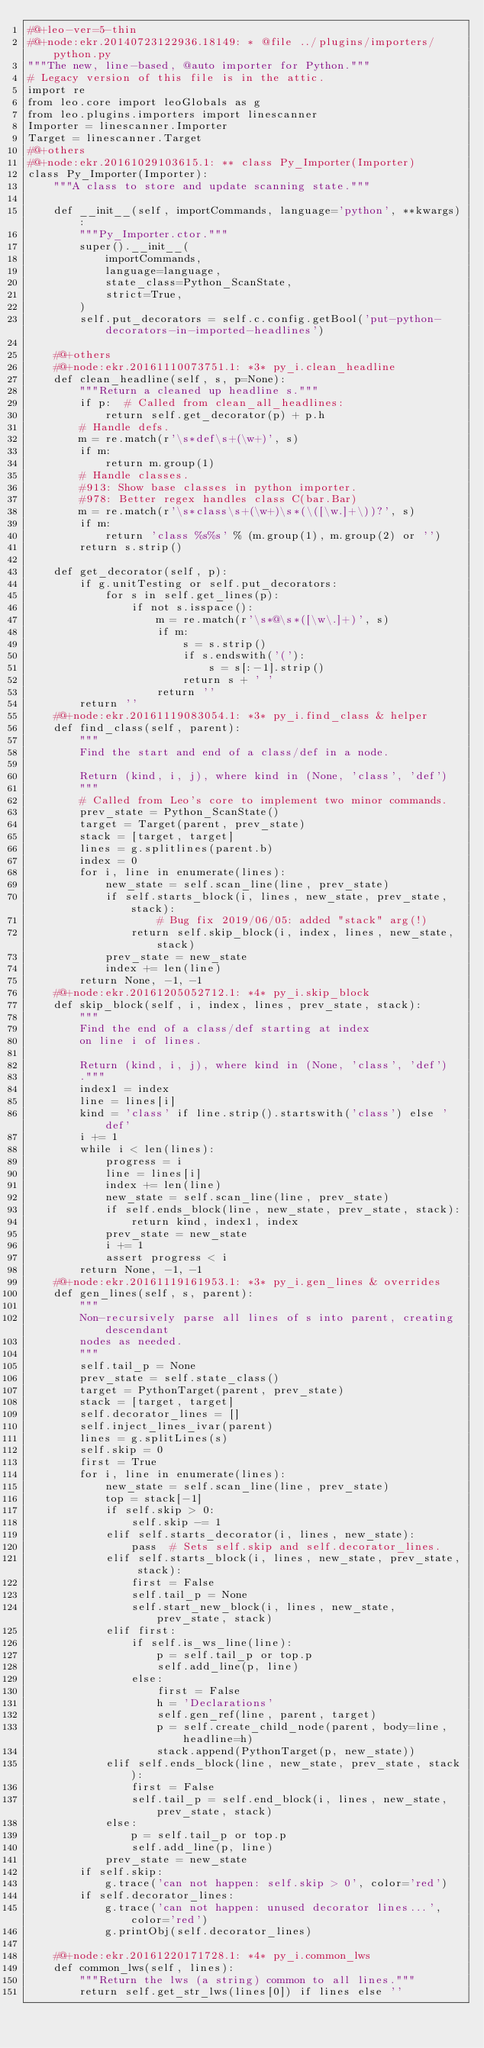<code> <loc_0><loc_0><loc_500><loc_500><_Python_>#@+leo-ver=5-thin
#@+node:ekr.20140723122936.18149: * @file ../plugins/importers/python.py
"""The new, line-based, @auto importer for Python."""
# Legacy version of this file is in the attic.
import re
from leo.core import leoGlobals as g
from leo.plugins.importers import linescanner
Importer = linescanner.Importer
Target = linescanner.Target
#@+others
#@+node:ekr.20161029103615.1: ** class Py_Importer(Importer)
class Py_Importer(Importer):
    """A class to store and update scanning state."""

    def __init__(self, importCommands, language='python', **kwargs):
        """Py_Importer.ctor."""
        super().__init__(
            importCommands,
            language=language,
            state_class=Python_ScanState,
            strict=True,
        )
        self.put_decorators = self.c.config.getBool('put-python-decorators-in-imported-headlines')

    #@+others
    #@+node:ekr.20161110073751.1: *3* py_i.clean_headline
    def clean_headline(self, s, p=None):
        """Return a cleaned up headline s."""
        if p:  # Called from clean_all_headlines:
            return self.get_decorator(p) + p.h
        # Handle defs.
        m = re.match(r'\s*def\s+(\w+)', s)
        if m:
            return m.group(1)
        # Handle classes.
        #913: Show base classes in python importer.
        #978: Better regex handles class C(bar.Bar)
        m = re.match(r'\s*class\s+(\w+)\s*(\([\w.]+\))?', s)
        if m:
            return 'class %s%s' % (m.group(1), m.group(2) or '')
        return s.strip()

    def get_decorator(self, p):
        if g.unitTesting or self.put_decorators:
            for s in self.get_lines(p):
                if not s.isspace():
                    m = re.match(r'\s*@\s*([\w\.]+)', s)
                    if m:
                        s = s.strip()
                        if s.endswith('('):
                            s = s[:-1].strip()
                        return s + ' '
                    return ''
        return ''
    #@+node:ekr.20161119083054.1: *3* py_i.find_class & helper
    def find_class(self, parent):
        """
        Find the start and end of a class/def in a node.

        Return (kind, i, j), where kind in (None, 'class', 'def')
        """
        # Called from Leo's core to implement two minor commands.
        prev_state = Python_ScanState()
        target = Target(parent, prev_state)
        stack = [target, target]
        lines = g.splitlines(parent.b)
        index = 0
        for i, line in enumerate(lines):
            new_state = self.scan_line(line, prev_state)
            if self.starts_block(i, lines, new_state, prev_state, stack):
                    # Bug fix 2019/06/05: added "stack" arg(!)
                return self.skip_block(i, index, lines, new_state, stack)
            prev_state = new_state
            index += len(line)
        return None, -1, -1
    #@+node:ekr.20161205052712.1: *4* py_i.skip_block
    def skip_block(self, i, index, lines, prev_state, stack):
        """
        Find the end of a class/def starting at index
        on line i of lines.

        Return (kind, i, j), where kind in (None, 'class', 'def')
        ."""
        index1 = index
        line = lines[i]
        kind = 'class' if line.strip().startswith('class') else 'def'
        i += 1
        while i < len(lines):
            progress = i
            line = lines[i]
            index += len(line)
            new_state = self.scan_line(line, prev_state)
            if self.ends_block(line, new_state, prev_state, stack):
                return kind, index1, index
            prev_state = new_state
            i += 1
            assert progress < i
        return None, -1, -1
    #@+node:ekr.20161119161953.1: *3* py_i.gen_lines & overrides
    def gen_lines(self, s, parent):
        """
        Non-recursively parse all lines of s into parent, creating descendant
        nodes as needed.
        """
        self.tail_p = None
        prev_state = self.state_class()
        target = PythonTarget(parent, prev_state)
        stack = [target, target]
        self.decorator_lines = []
        self.inject_lines_ivar(parent)
        lines = g.splitLines(s)
        self.skip = 0
        first = True
        for i, line in enumerate(lines):
            new_state = self.scan_line(line, prev_state)
            top = stack[-1]
            if self.skip > 0:
                self.skip -= 1
            elif self.starts_decorator(i, lines, new_state):
                pass  # Sets self.skip and self.decorator_lines.
            elif self.starts_block(i, lines, new_state, prev_state, stack):
                first = False
                self.tail_p = None
                self.start_new_block(i, lines, new_state, prev_state, stack)
            elif first:
                if self.is_ws_line(line):
                    p = self.tail_p or top.p
                    self.add_line(p, line)
                else:
                    first = False
                    h = 'Declarations'
                    self.gen_ref(line, parent, target)
                    p = self.create_child_node(parent, body=line, headline=h)
                    stack.append(PythonTarget(p, new_state))
            elif self.ends_block(line, new_state, prev_state, stack):
                first = False
                self.tail_p = self.end_block(i, lines, new_state, prev_state, stack)
            else:
                p = self.tail_p or top.p
                self.add_line(p, line)
            prev_state = new_state
        if self.skip:
            g.trace('can not happen: self.skip > 0', color='red')
        if self.decorator_lines:
            g.trace('can not happen: unused decorator lines...', color='red')
            g.printObj(self.decorator_lines)

    #@+node:ekr.20161220171728.1: *4* py_i.common_lws
    def common_lws(self, lines):
        """Return the lws (a string) common to all lines."""
        return self.get_str_lws(lines[0]) if lines else ''</code> 